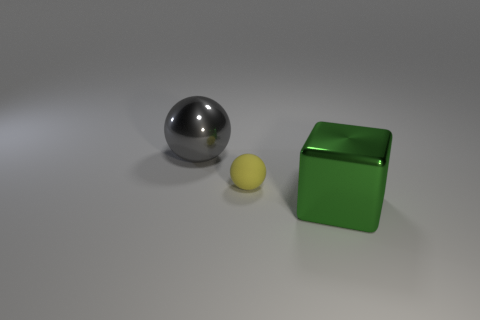Add 1 small green objects. How many objects exist? 4 Subtract all yellow spheres. How many spheres are left? 1 Subtract 2 balls. How many balls are left? 0 Subtract all blocks. How many objects are left? 2 Subtract all green metal blocks. Subtract all large gray metal objects. How many objects are left? 1 Add 3 big green shiny cubes. How many big green shiny cubes are left? 4 Add 1 large yellow blocks. How many large yellow blocks exist? 1 Subtract 0 green spheres. How many objects are left? 3 Subtract all yellow balls. Subtract all yellow blocks. How many balls are left? 1 Subtract all green cylinders. How many cyan blocks are left? 0 